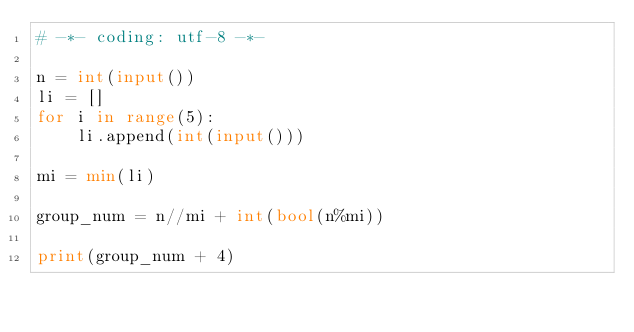Convert code to text. <code><loc_0><loc_0><loc_500><loc_500><_Python_># -*- coding: utf-8 -*-

n = int(input())
li = []
for i in range(5):
    li.append(int(input()))

mi = min(li)

group_num = n//mi + int(bool(n%mi))

print(group_num + 4)</code> 